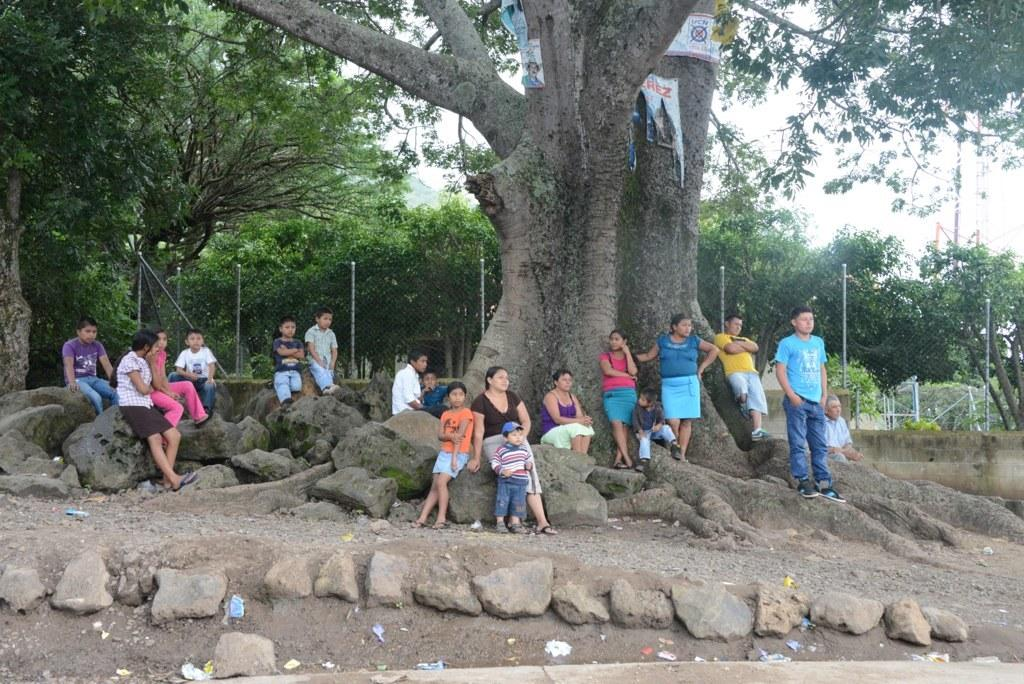What type of animals can be seen in the field in the image? The animals include cows, sheep, and horses. Where are the animals located in the image? The animals are in a field. What can be seen in the background of the image? There are trees and a fence in the background of the image. What is the brother of the horse doing in the image? There is no mention of a brother for any of the animals in the image. Can you describe the digestion process of the cows in the image? The image does not provide information about the digestion process of the cows; it only shows them in a field. 